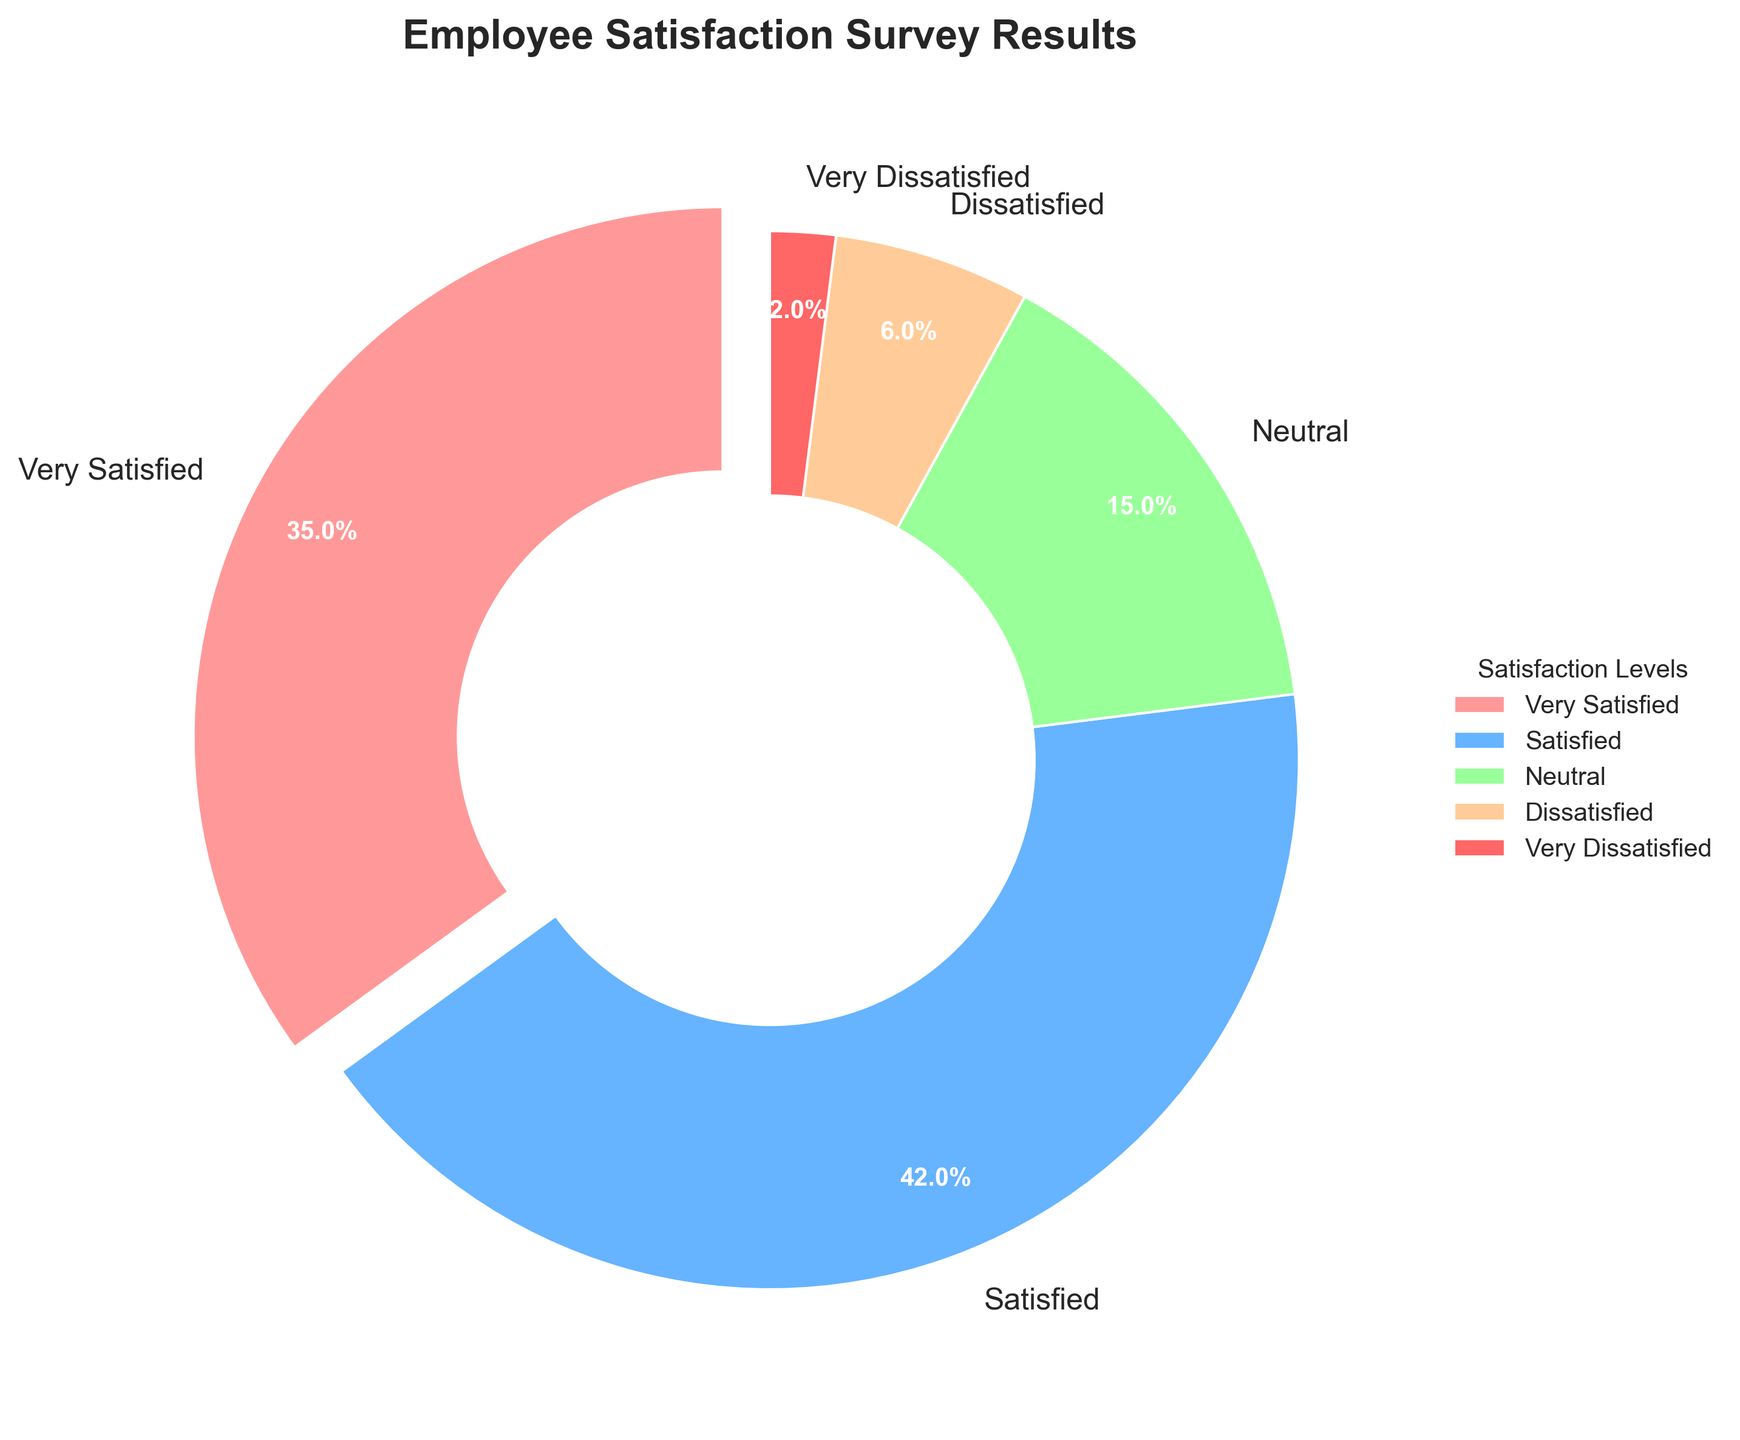What percentage of employees are either Very Satisfied or Satisfied? Add the percentages of Very Satisfied and Satisfied. Very Satisfied is 35% and Satisfied is 42%. The total is 35% + 42% = 77%.
Answer: 77% Which satisfaction level has the highest percentage? Look at the chart and identify the largest segment. The largest segment corresponds to the "Satisfied" category. The chart lists its percentage as 42%.
Answer: Satisfied What is the difference in percentage between Neutral and Dissatisfied employees? Find the percentages for Neutral and Dissatisfied. Neutral is 15%, and Dissatisfied is 6%. The difference is 15% - 6% = 9%.
Answer: 9% How many categories have a percentage less than or equal to 15%? Examine the chart and count the segments with percentages less than or equal to 15%. These categories are Neutral (15%), Dissatisfied (6%), and Very Dissatisfied (2%). There are 3 such categories.
Answer: 3 Which satisfaction level has the smallest percentage, and what is it? Identify the smallest segment in the chart. The smallest segment corresponds to "Very Dissatisfied" with a percentage of 2%.
Answer: Very Dissatisfied, 2% How does the percentage of Neutral employees compare to Very Satisfied employees? Compare the percentages directly. Neutral is 15%, and Very Satisfied is 35%. 35% is greater than 15%.
Answer: Very Satisfied percentage is higher than Neutral What is the combined percentage of employees who are Neutral or less satisfied? Sum the percentages for Neutral, Dissatisfied, and Very Dissatisfied. Neutral is 15%, Dissatisfied is 6%, and Very Dissatisfied is 2%. The total is 15% + 6% + 2% = 23%.
Answer: 23% Which satisfaction levels have more than 30% of employees? Check each category's percentage. Very Satisfied has 35%, and Satisfied has 42%. Both are more than 30%.
Answer: Very Satisfied, Satisfied What is the visual representation color for the "Dissatisfied" category? Identify the color used for the "Dissatisfied" segment in the chart. The "Dissatisfied" category is represented by an orange color.
Answer: Orange What percentage of employees are not in the "Satisfied" category? To find the percentage of employees not in the "Satisfied" category, subtract the percentage of this category from 100%. Satisfied is 42%, so 100% - 42% = 58%.
Answer: 58% 